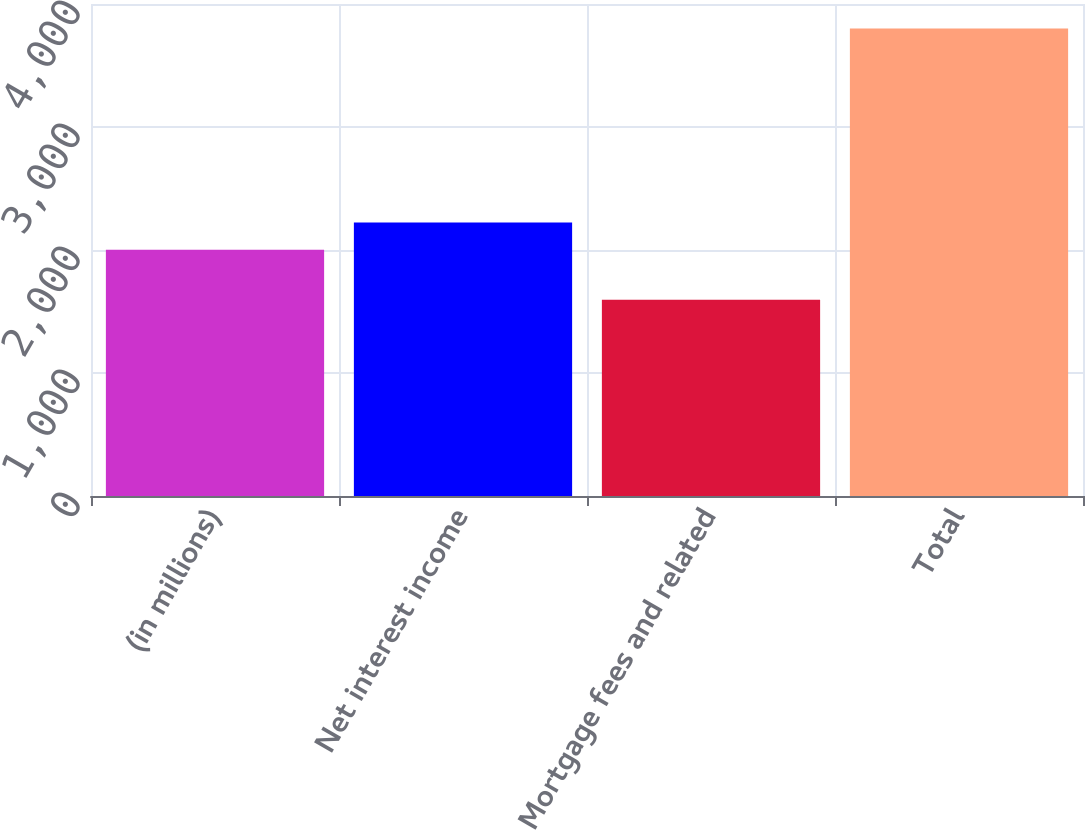Convert chart to OTSL. <chart><loc_0><loc_0><loc_500><loc_500><bar_chart><fcel>(in millions)<fcel>Net interest income<fcel>Mortgage fees and related<fcel>Total<nl><fcel>2003<fcel>2223.4<fcel>1596<fcel>3800<nl></chart> 